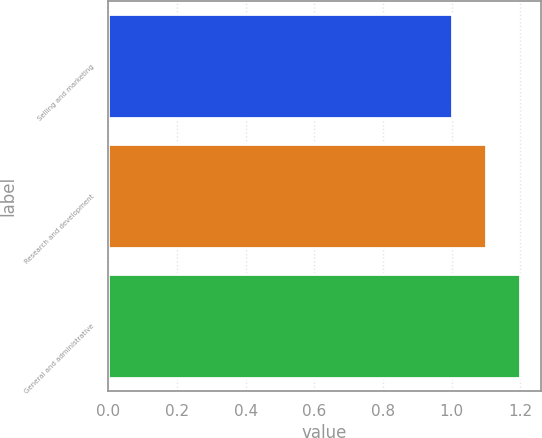Convert chart. <chart><loc_0><loc_0><loc_500><loc_500><bar_chart><fcel>Selling and marketing<fcel>Research and development<fcel>General and administrative<nl><fcel>1<fcel>1.1<fcel>1.2<nl></chart> 